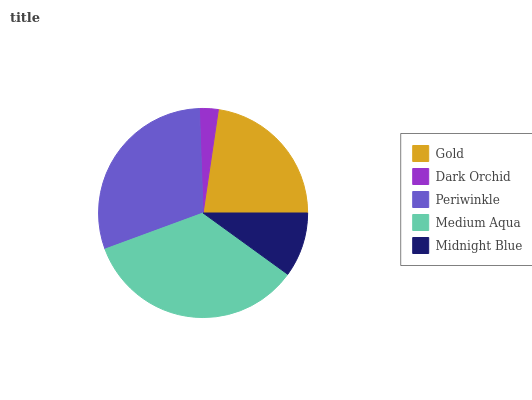Is Dark Orchid the minimum?
Answer yes or no. Yes. Is Medium Aqua the maximum?
Answer yes or no. Yes. Is Periwinkle the minimum?
Answer yes or no. No. Is Periwinkle the maximum?
Answer yes or no. No. Is Periwinkle greater than Dark Orchid?
Answer yes or no. Yes. Is Dark Orchid less than Periwinkle?
Answer yes or no. Yes. Is Dark Orchid greater than Periwinkle?
Answer yes or no. No. Is Periwinkle less than Dark Orchid?
Answer yes or no. No. Is Gold the high median?
Answer yes or no. Yes. Is Gold the low median?
Answer yes or no. Yes. Is Dark Orchid the high median?
Answer yes or no. No. Is Periwinkle the low median?
Answer yes or no. No. 